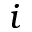<formula> <loc_0><loc_0><loc_500><loc_500>i</formula> 